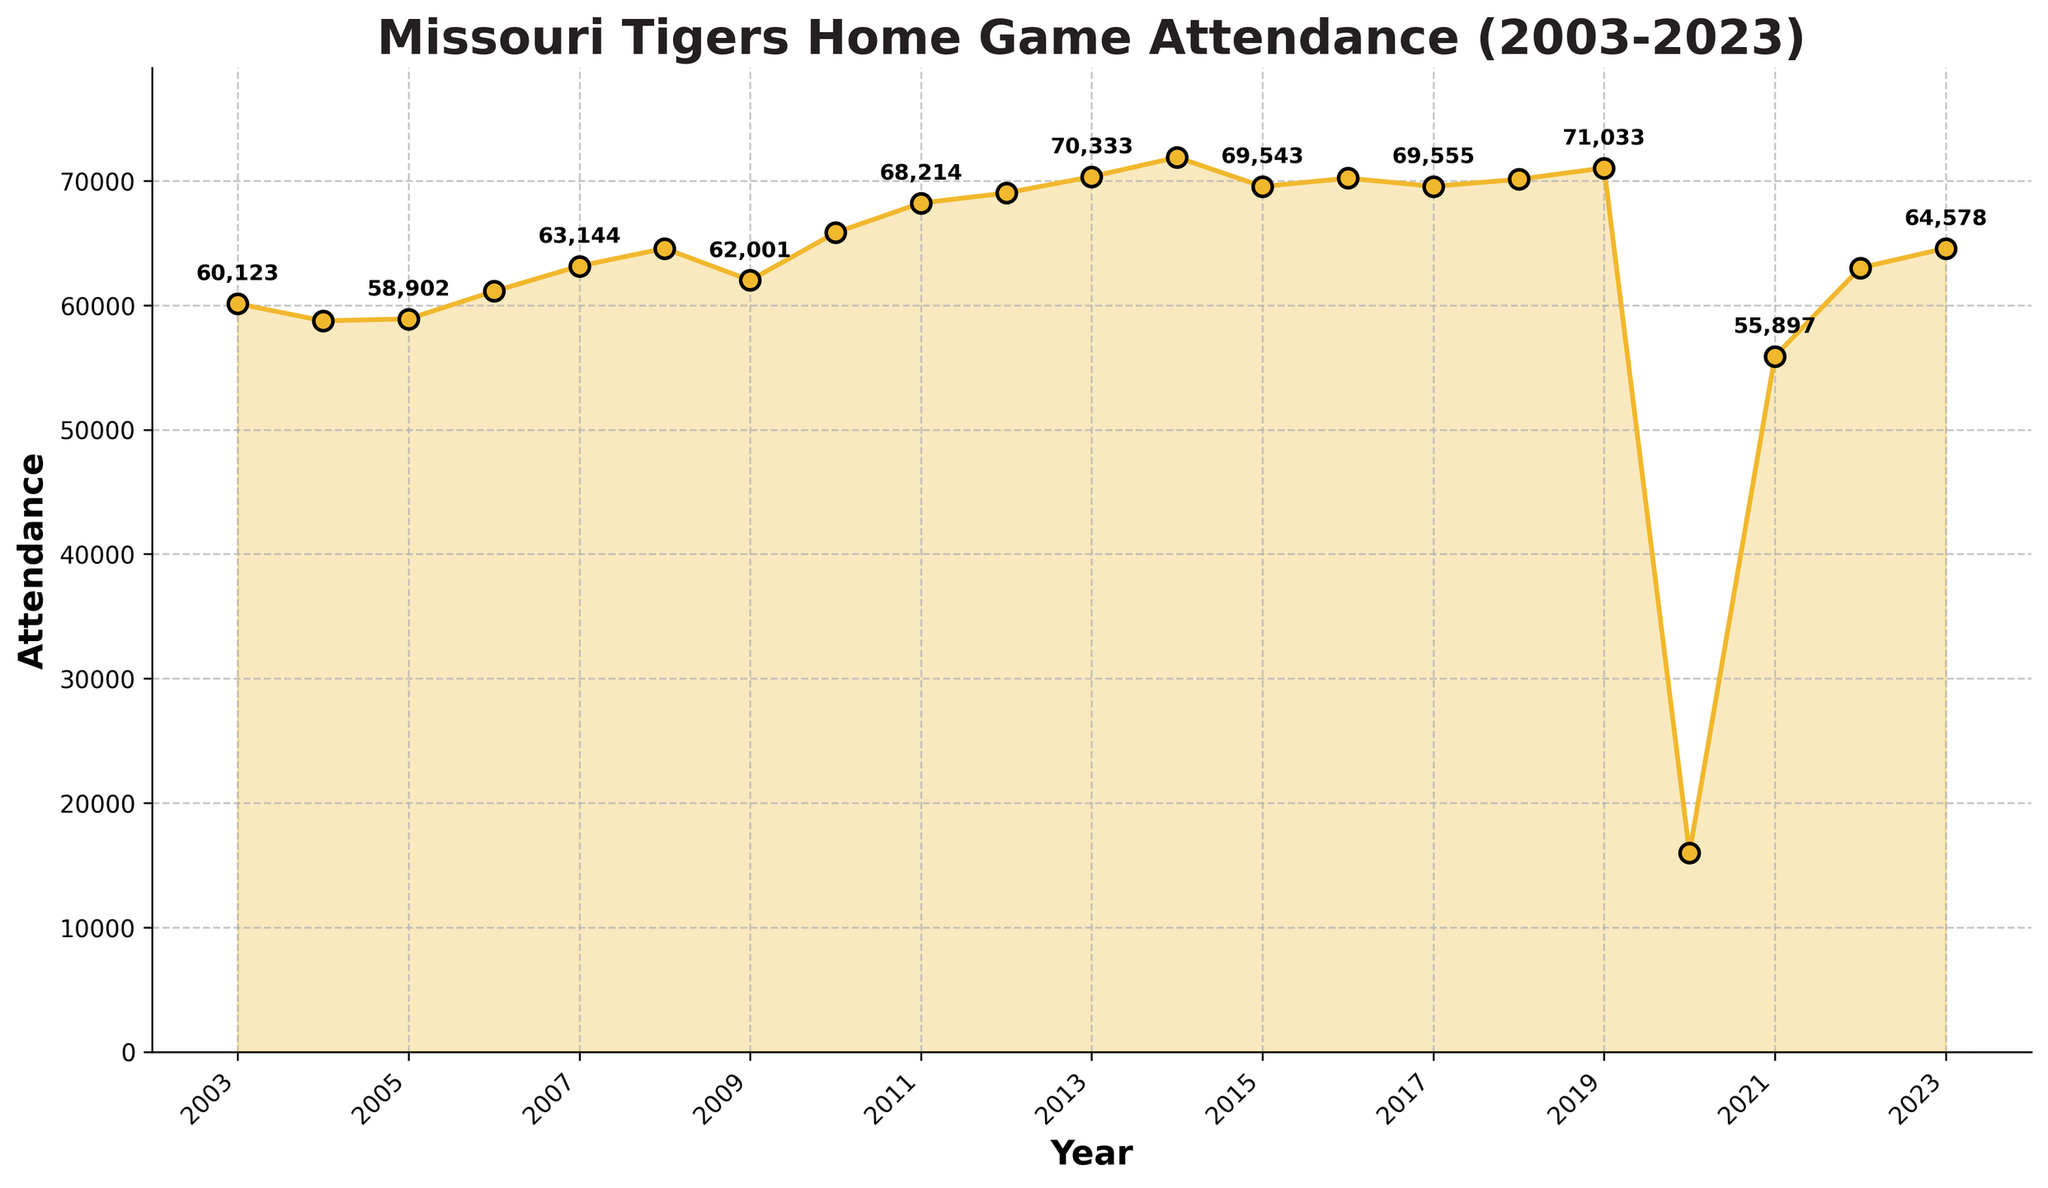Which year had the highest home game attendance? Look at the peak point on the time series plot, which shows the year 2014 with the highest attendance.
Answer: 2014 What was the attendance trend from 2014 to 2016? Observe the sections of the plot corresponding to the years 2014 to 2016. The attendance decreased from 2014 (71,890) to 2015 (69,543), and then it slightly increased to 2016 (70,211).
Answer: Decreased, then slightly increased How did the attendance change in 2020 compared to 2019? Examine the plot points for the years 2019 (71,033) and 2020 (15,984). The attendance significantly dropped in 2020 compared to 2019.
Answer: Decreased significantly What's the average attendance over the past 20 years? Calculate the average by summing up all attendance figures and dividing by the number of years (20). Total sum is 1,365,924, and 1,365,924 / 20 = 68,296.2.
Answer: 68,296.2 Which year had the lowest home game attendance? Identify the lowest point on the time series plot, which shows the year 2020 with the lowest attendance.
Answer: 2020 How did the attendance change from 2021 to 2023? Look at the plot points for 2021 (55,897), 2022 (63,004), and 2023 (64,578). The attendance increased each year from 2021 to 2023.
Answer: Increased What is the median attendance over the 20 years? List all attendance values in ascending order and find the middle value. With an even number of points (20), the median is the average of the 10th and 11th values. The median is (69,021 + 69,333)/2 = 69,177.
Answer: 69,177 During which period did the attendance peak twice in close succession? Observe the plot for two prominent peaks. From 2010 (65,833), there are peaks in 2011 (68,214), and 2012 (69,021) in close succession.
Answer: 2010-2012 Which year had similar attendance figures to 2023? Compare attendance of 2023 (64,578) with other years' figures. The year 2008 had a close figure (64,567).
Answer: 2008 How did the attendance trend from 2003 to 2008? Examine the attendance from 2003 (60,123) to 2008 (64,567), identifying a gradual increase each year.
Answer: Gradually increased 